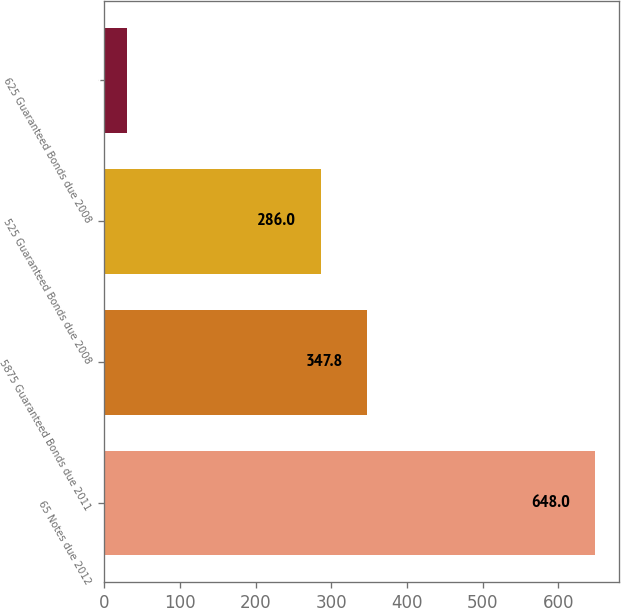Convert chart. <chart><loc_0><loc_0><loc_500><loc_500><bar_chart><fcel>65 Notes due 2012<fcel>5875 Guaranteed Bonds due 2011<fcel>525 Guaranteed Bonds due 2008<fcel>625 Guaranteed Bonds due 2008<nl><fcel>648<fcel>347.8<fcel>286<fcel>30<nl></chart> 